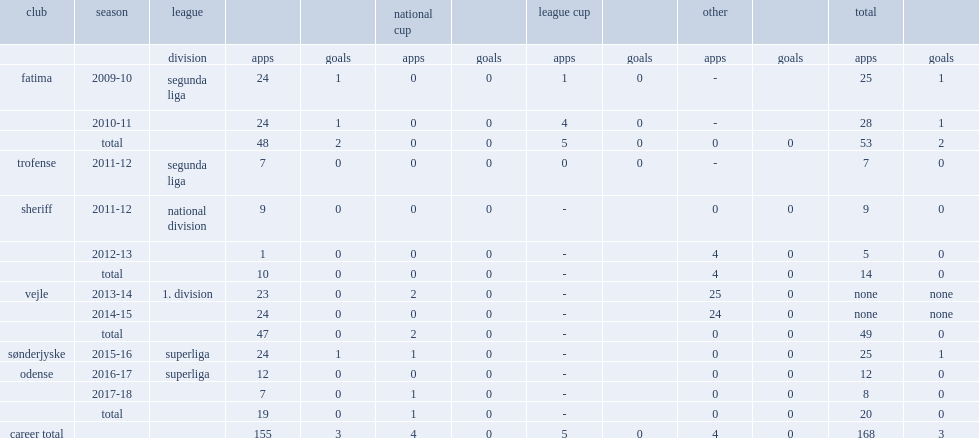Which league did joao pereira sign with odense boldklub in the 2016-17 campaign? Superliga. 